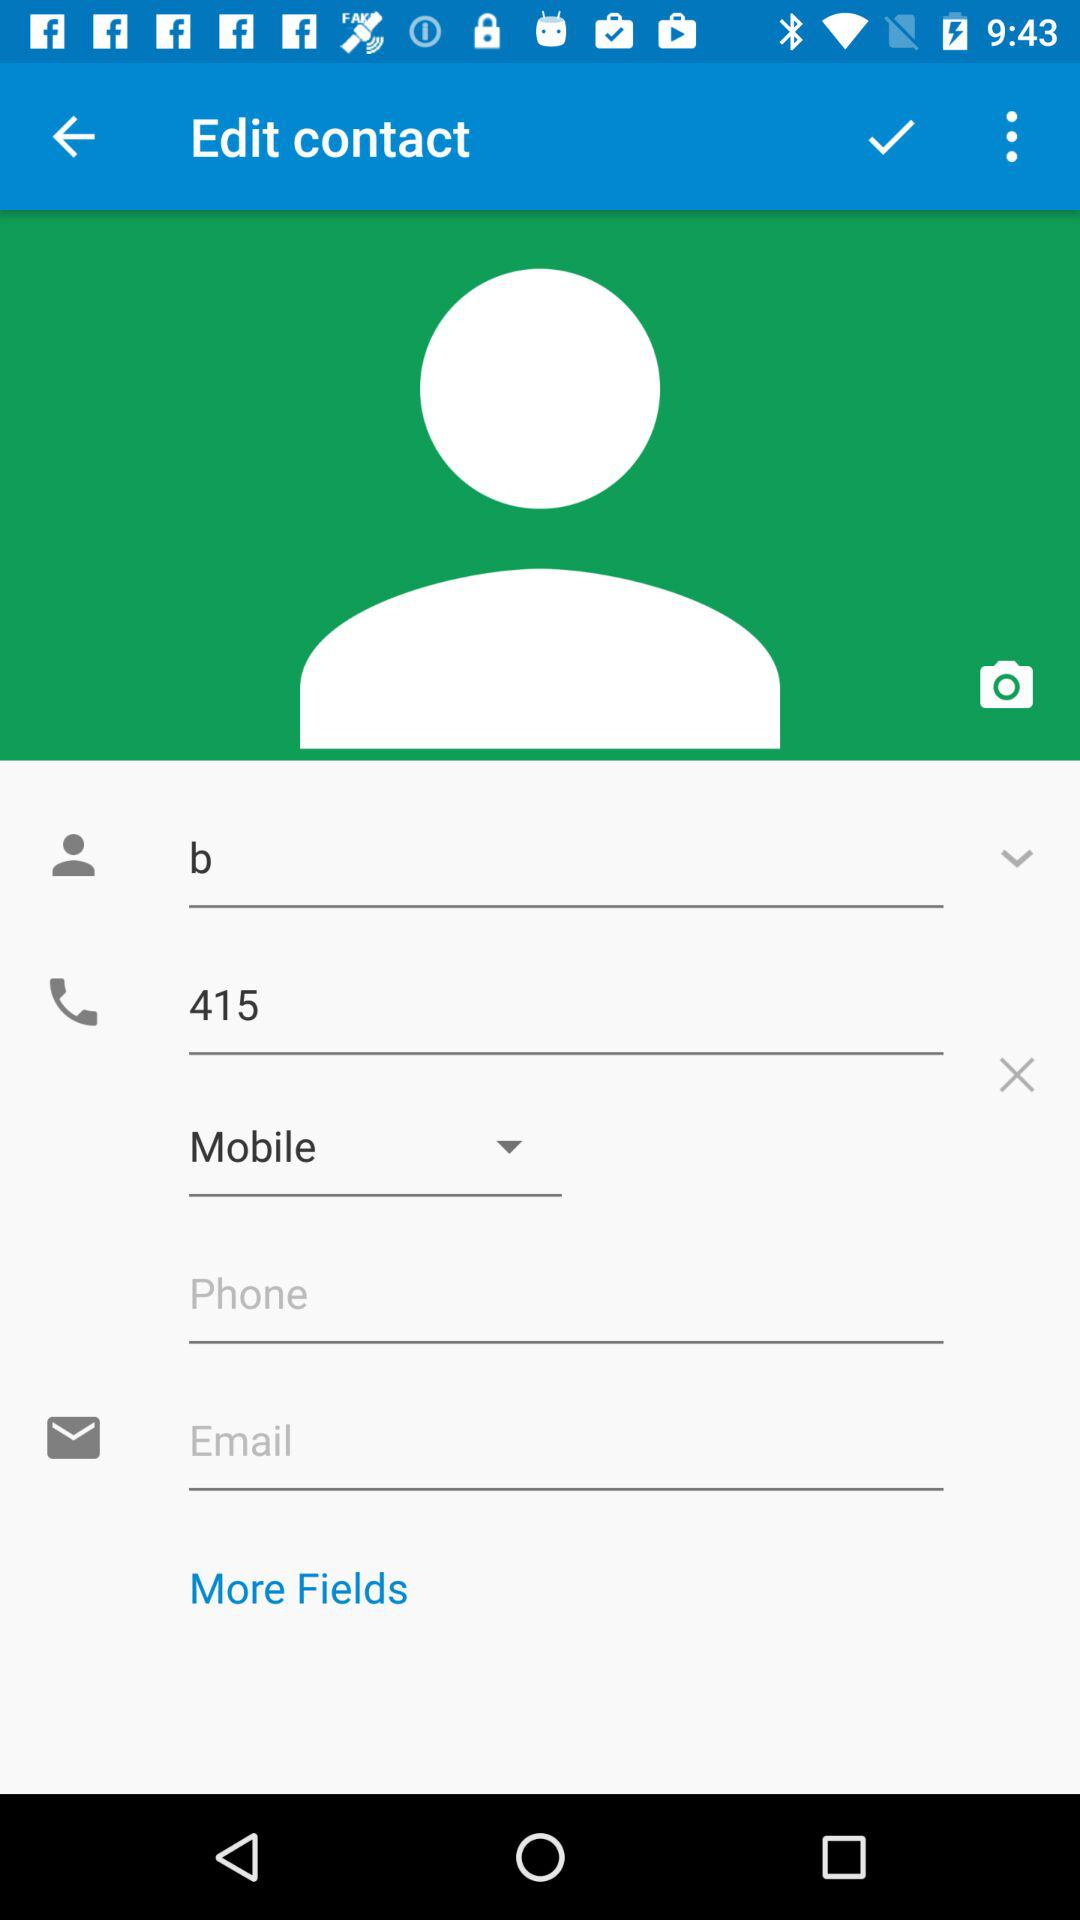What is the phone number? The phone number is 415. 